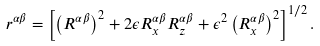<formula> <loc_0><loc_0><loc_500><loc_500>r ^ { \alpha \beta } = \left [ \left ( R ^ { \alpha \beta } \right ) ^ { 2 } + 2 \epsilon R _ { x } ^ { \alpha \beta } R _ { z } ^ { \alpha \beta } + \epsilon ^ { 2 } \left ( R _ { x } ^ { \alpha \beta } \right ) ^ { 2 } \right ] ^ { 1 / 2 } .</formula> 